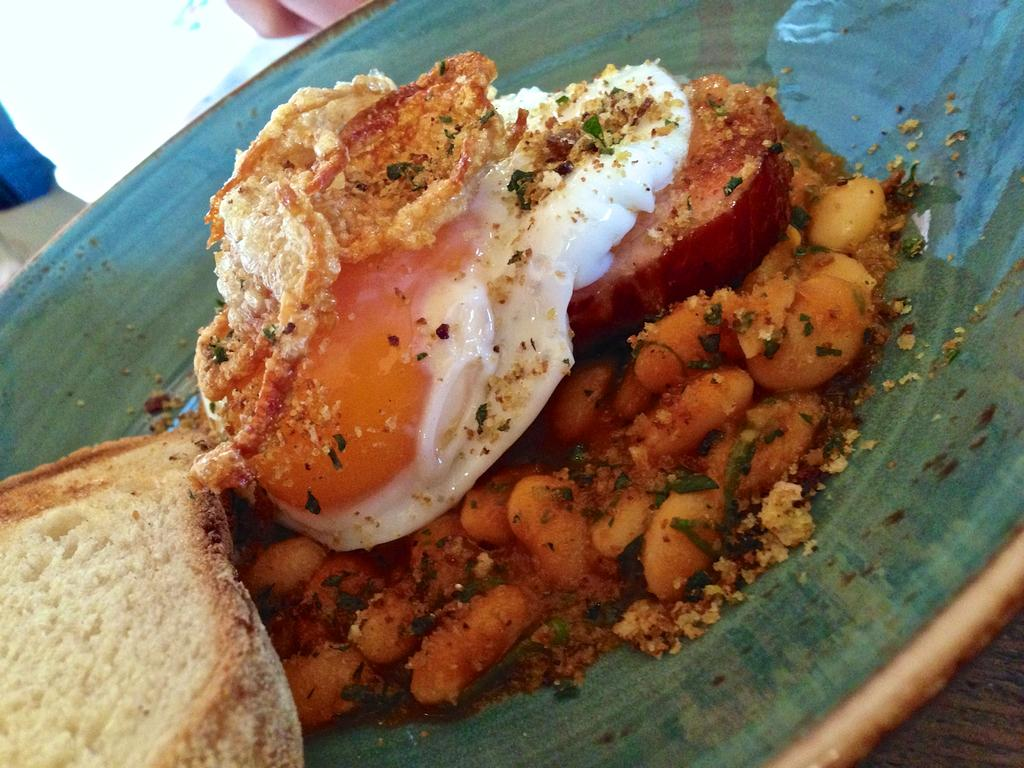What is the main subject of the image? The main subject of the image is a platter containing food items. Where is the platter located in the image? The platter is in the center of the image. What can be seen in the background of the image? There is a white color object in the background of the image. How many hearts can be seen on the platter in the image? There are no hearts visible on the platter in the image. What type of fruit, quince, can be seen on the platter in the image? There is no quince present on the platter in the image. 